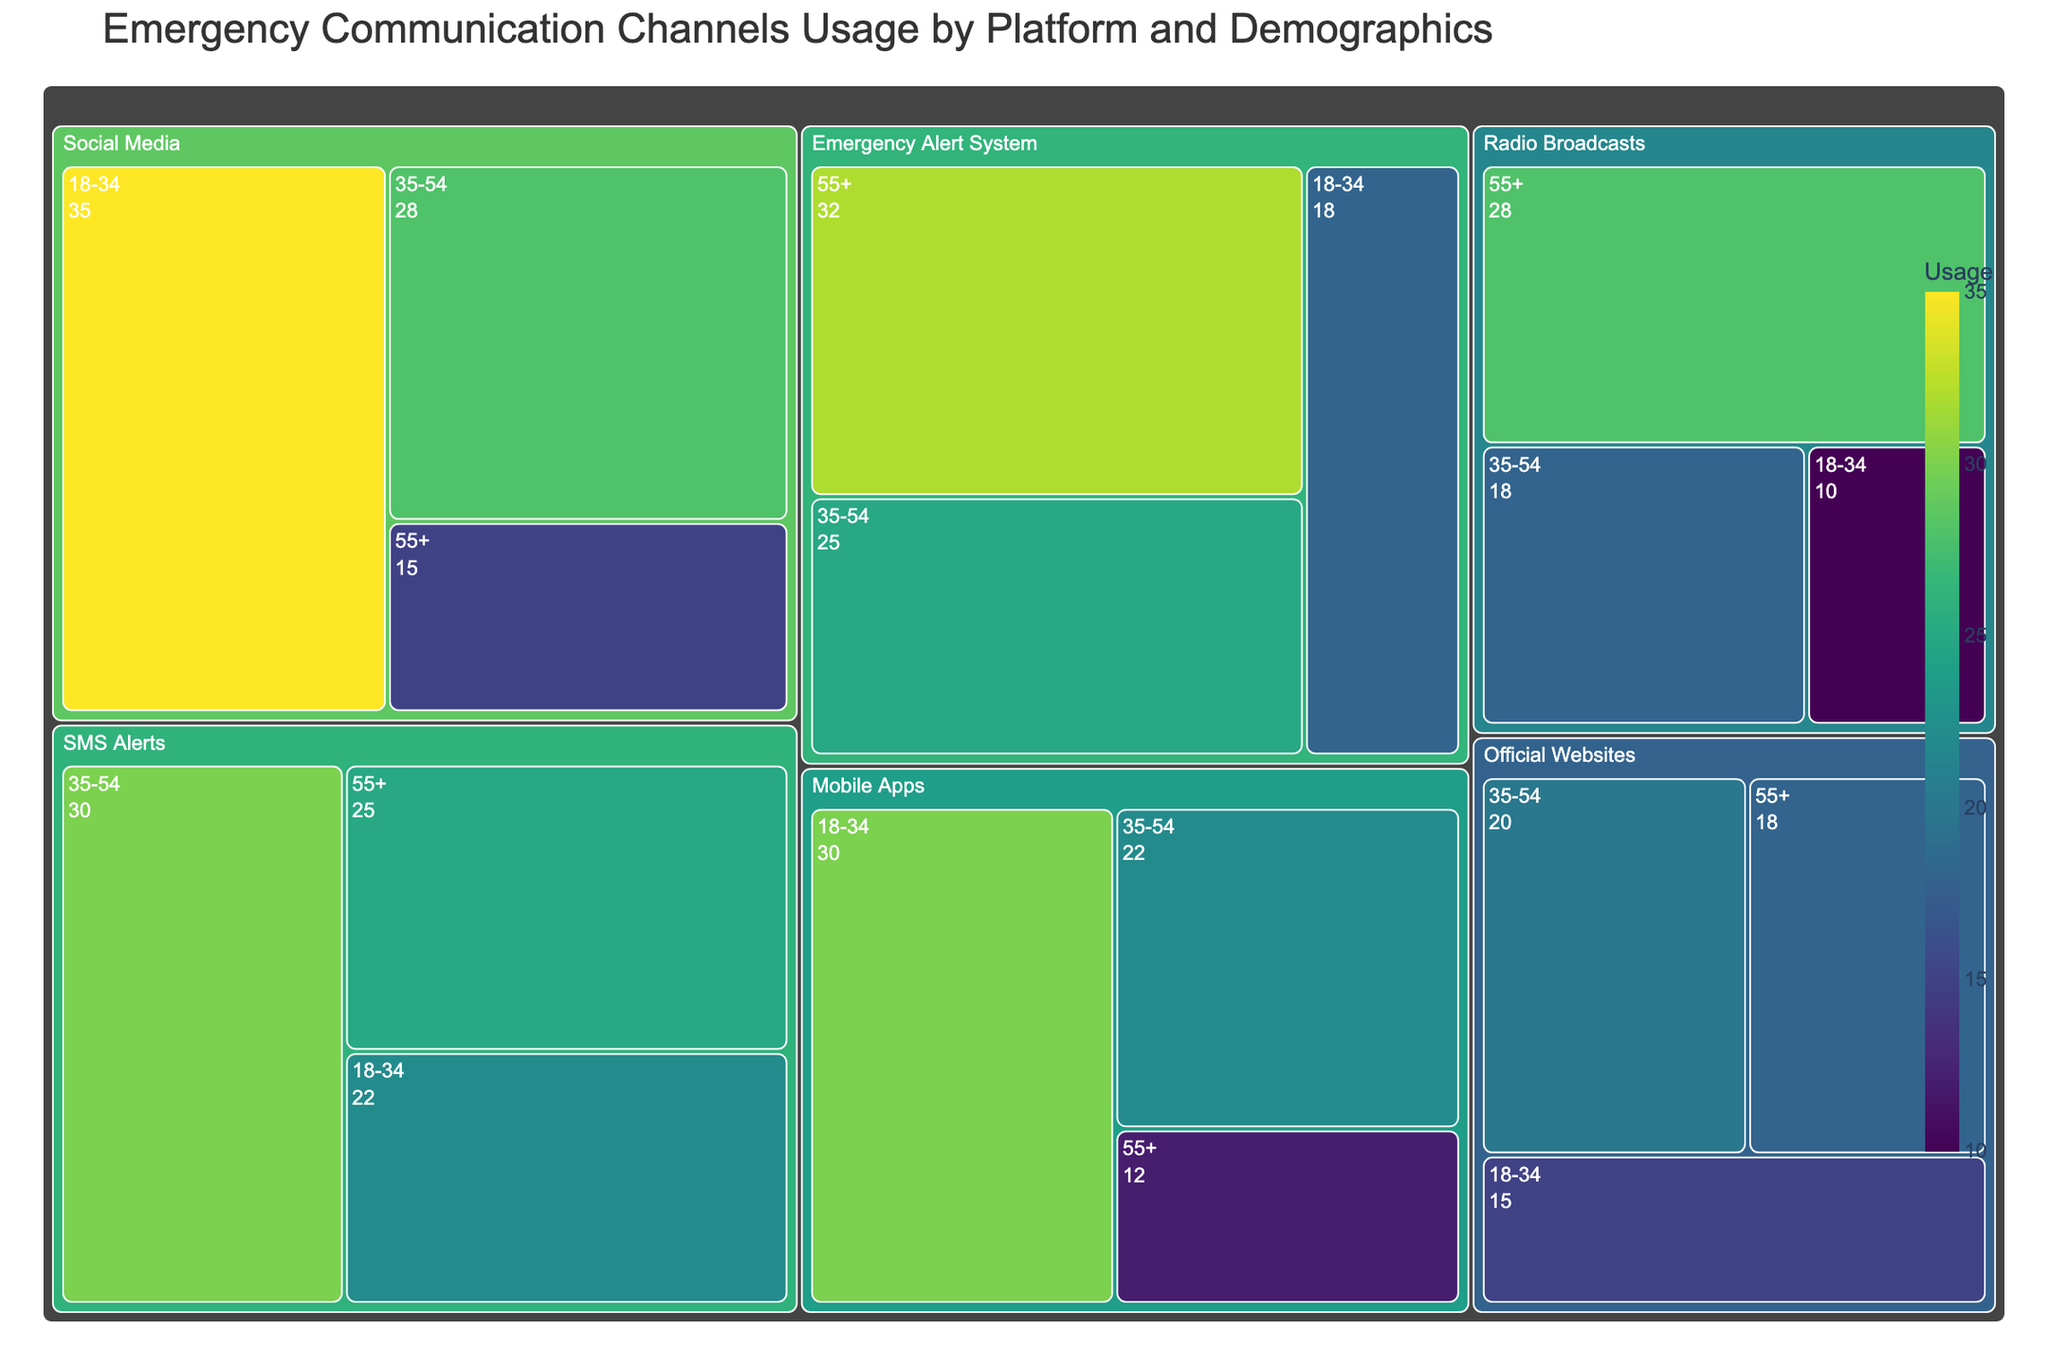How is the title of the figure framed? The title is positioned at the top of the figure and describes the main content, which is about the usage of emergency communication channels by platform and demographic groups.
Answer: Emergency Communication Channels Usage by Platform and Demographics Which communication platform shows the highest usage among the 18-34 demographic? By examining the treemap, the platform with the highest usage for the 18-34 demographic can be identified by finding the largest segment within that group. Social Media has the largest block for this demographic.
Answer: Social Media How does the usage of SMS Alerts compare between the 35-54 and the 55+ demographic groups? By comparing the usage values shown for SMS Alerts in the 35-54 demographic (30) and the 55+ demographic (25), we can determine that the 35-54 group has a higher usage.
Answer: 35-54 What is the total usage for Radio Broadcasts across all demographics? To find this, add the usage values for all demographic groups under Radio Broadcasts: 10 (18-34) + 18 (35-54) + 28 (55+). The sum is 56.
Answer: 56 Which platform has the least usage within the 18-34 demographic? By reviewing the usage values for all platforms within the 18-34 demographic, Radio Broadcasts shows the lowest usage at 10.
Answer: Radio Broadcasts How does the usage of Mobile Apps differ between the 18-34 and the 55+ demographics? By checking the treemap, Mobile Apps usage for the 18-34 demographic is 30, whereas usage for the 55+ demographic is 12. This shows that the younger demographic has a significantly higher usage.
Answer: Significant difference, higher for 18-34 Can you identify the platform with the highest usage among the 55+ demographic? By examining the treemap segments for the 55+ demographic, the Emergency Alert System shows the highest usage value at 32.
Answer: Emergency Alert System What is the average usage of Official Websites across all demographics? Calculate the average by summing the usage values of Official Websites across all demographics (18-34: 15, 35-54: 20, 55+: 18) and dividing by the number of demographics: (15 + 20 + 18) / 3 = 17.67.
Answer: 17.67 